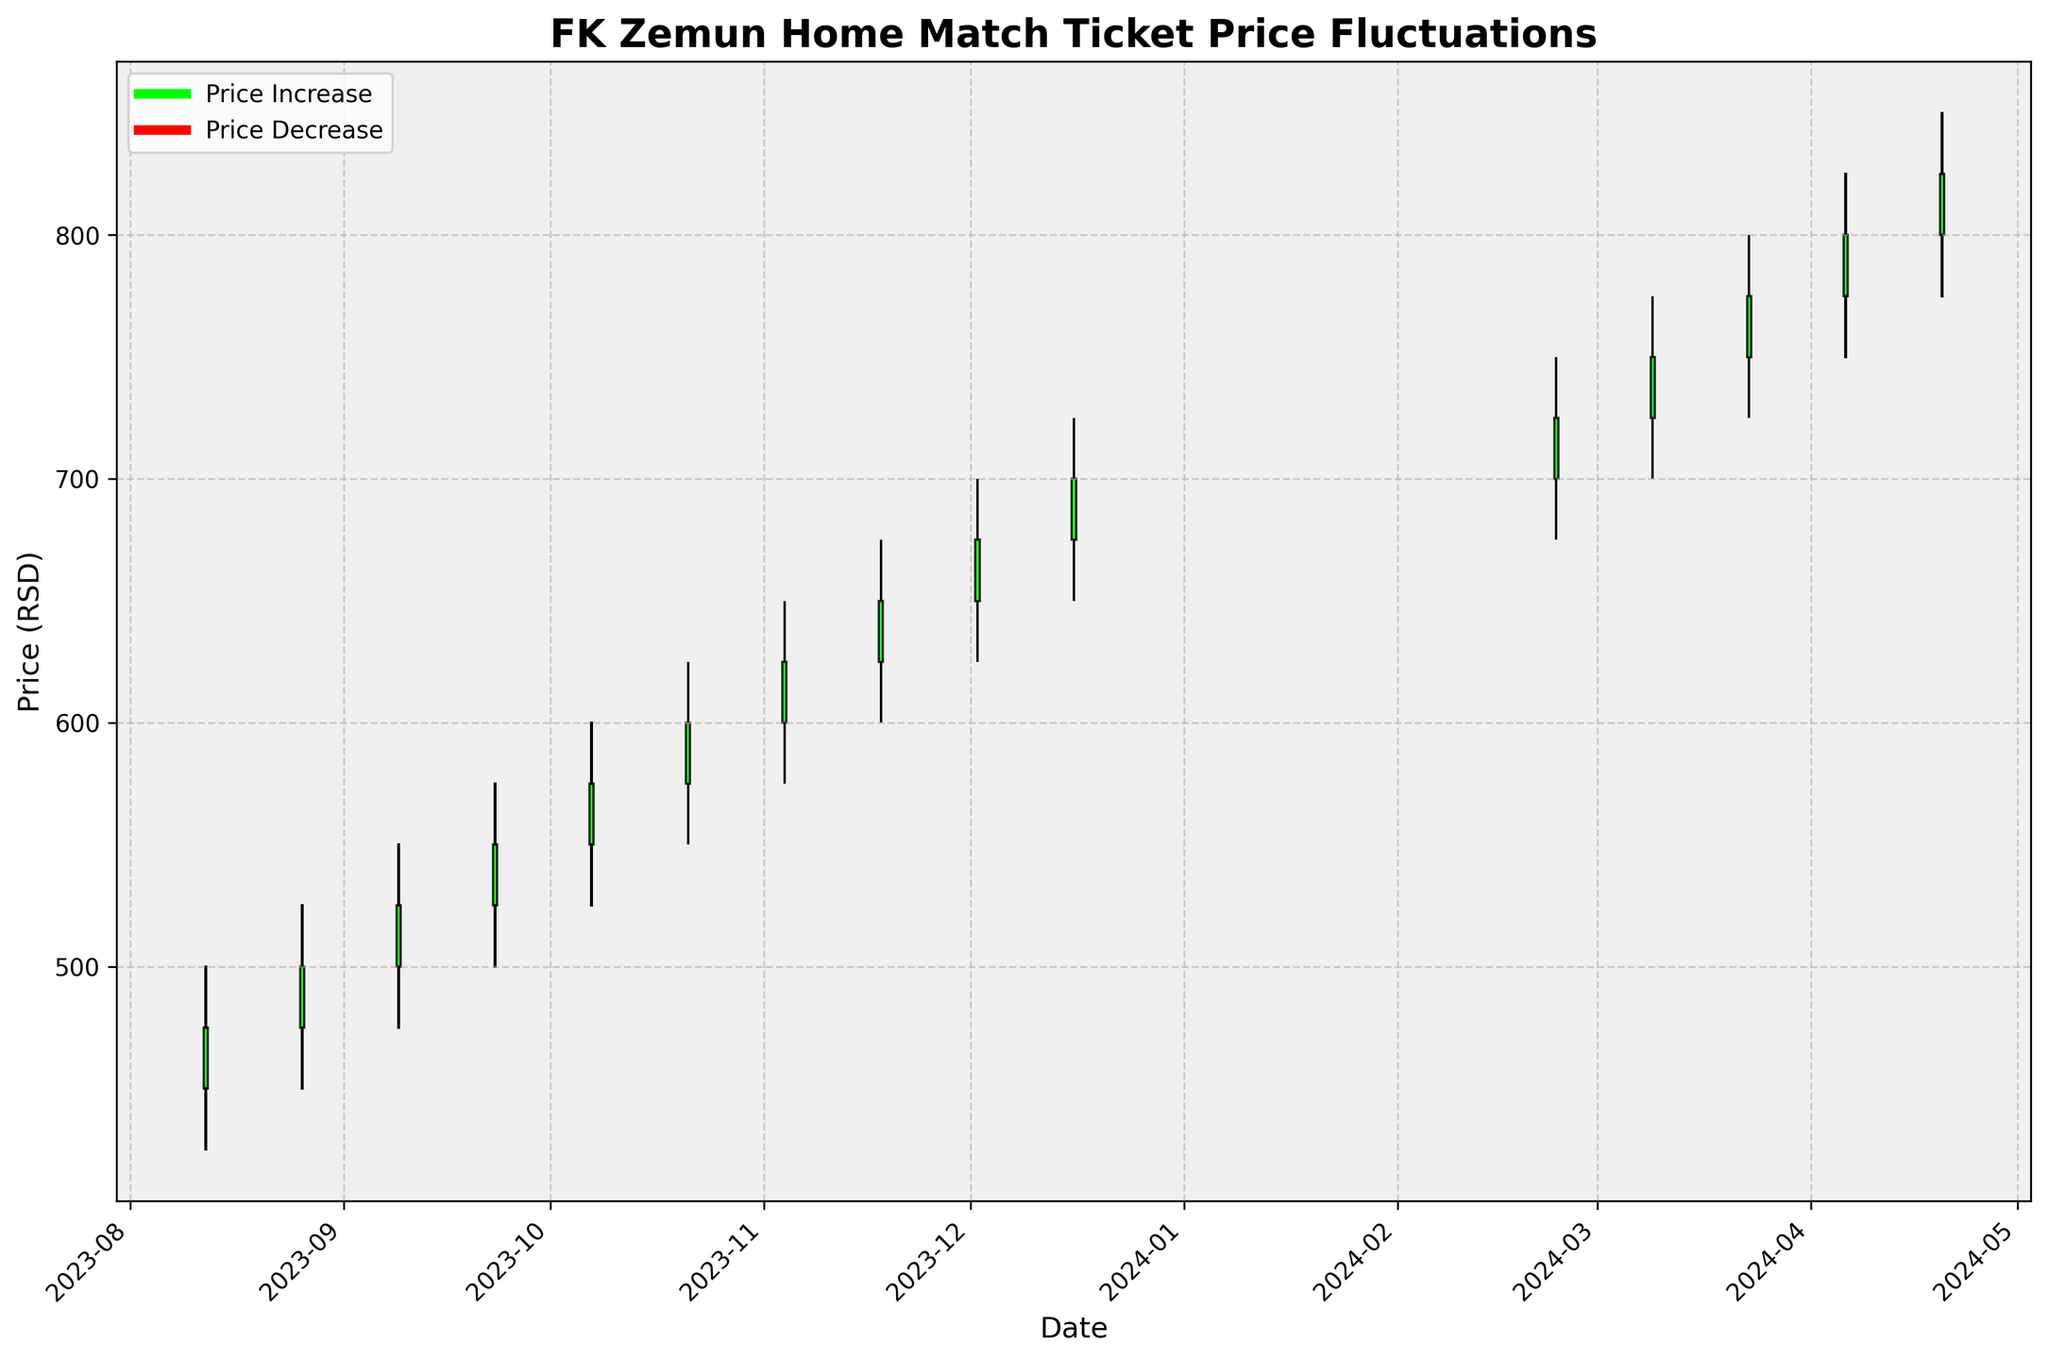What is the highest price reached for FK Zemun home match tickets in the season? The highest price reached is visibly marked by the highest point on the chart. It occurs on 2024-04-20 where the High value for that date is 850 RSD.
Answer: 850 RSD On which date did the ticket price open at 500 RSD? By looking through the OHLC chart, the open price of 500 RSD can be identified for the date 2023-09-09.
Answer: 2023-09-09 How many times did the ticket prices increase from the open to the close during the season? We count the green bars since these represent the days when the close price was higher than the open price. There are 8 such bars.
Answer: 8 times What is the average closing price of the tickets throughout the season? To find the average closing price, sum all the closing prices and divide by the number of data points. The closing prices are: 475, 500, 525, 550, 575, 600, 625, 650, 675, 700, 725, 750, 775, 800, 825. Their sum = 9875. There are 15 data points, so 9875 / 15 = 658.33.
Answer: 658.33 RSD Which date witnessed the largest price decrease from the high to the low during the day? The largest difference between high and low values can be found by calculating the differences and identifying the maximum. The largest decrease is on 2023-08-26, with a high of 525 and a low of 450, so the difference is 75.
Answer: 2023-08-26 How did the ticket price on 2023-10-07 compare to the previous date of 2023-09-23 in terms of closing? Check the close prices for 2023-09-23 and 2023-10-07. On 2023-09-23, the closing price was 550 RSD, and on 2023-10-07, it was 575 RSD. The price increased by 25 RSD.
Answer: Increased by 25 RSD What was the overall trend in ticket prices from the start to the end of the period? Observing the chart, the ticket prices consistently increased over the dates from 450 RSD on 2023-08-12 to 825 RSD on 2024-04-20. This illustrates a clear upward trend.
Answer: Upward trend Which month had the highest average closing price? Calculate the average closing price for each month, and then identify the highest. Summarize the averages: August: (475+500)/2 = 487.5, September: (525+550)/2 = 537.5, October: (575+600)/2 = 587.5, November: (625+650)/2 = 637.5, December: (675+700)/2 = 687.5, February: 725, March: (750+775)/2 = 762.5, April: (800+825)/2 = 812.5. April has the highest average closing price.
Answer: April 